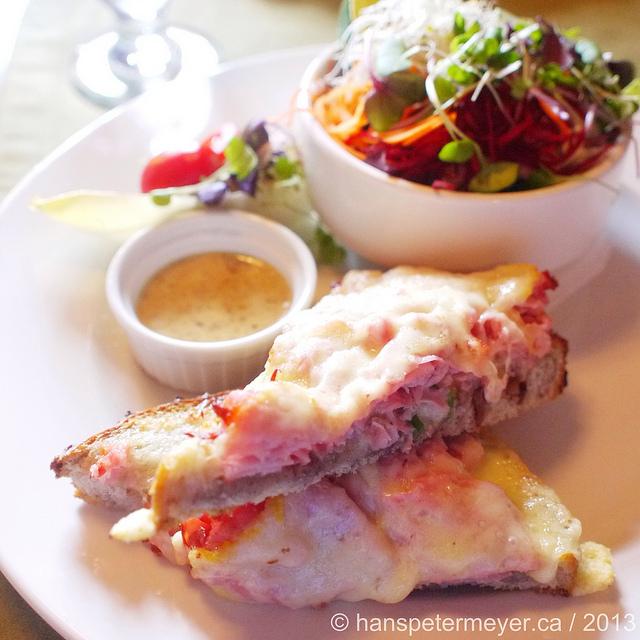What is healthy on the plate?
Short answer required. Salad. What kind of main dish is there?
Concise answer only. Pizza. How many bowls?
Write a very short answer. 2. 